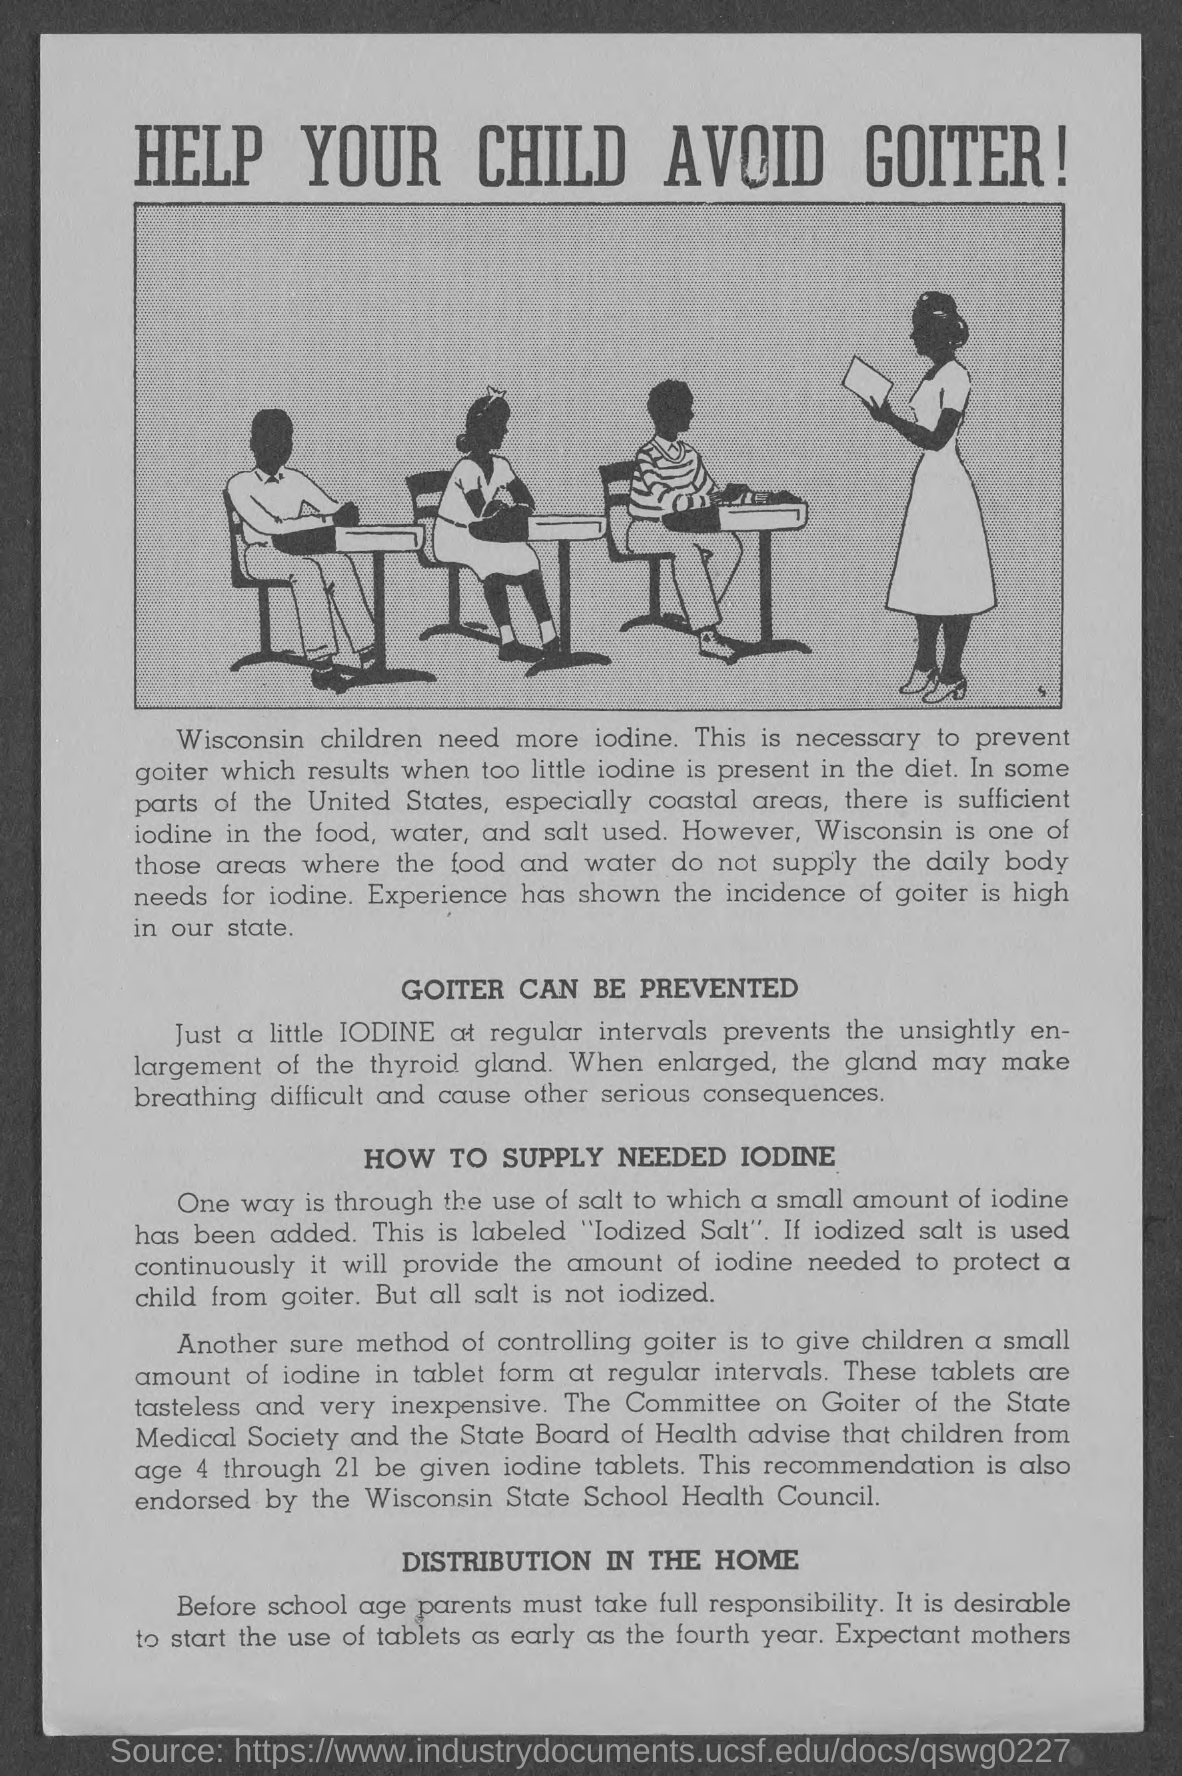Point out several critical features in this image. The third paragraph's heading is 'How to Supply Necessary Iodine,' which provides a comprehensive guide for obtaining and incorporating iodine into one's diet. The heading of the fourth paragraph is "Distribution in the Home. The heading at the top of the page is 'Help Your Child Avoid Goiter,' which is a condition that can cause swelling in the neck, and it is important for parents to provide their children with a healthy diet to prevent it. Goiter can be prevented through proper nutrition and iodine supplementation. 